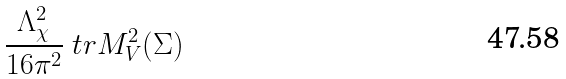Convert formula to latex. <formula><loc_0><loc_0><loc_500><loc_500>\frac { \Lambda _ { \chi } ^ { 2 } } { 1 6 \pi ^ { 2 } } \ t r M _ { V } ^ { 2 } ( \Sigma )</formula> 